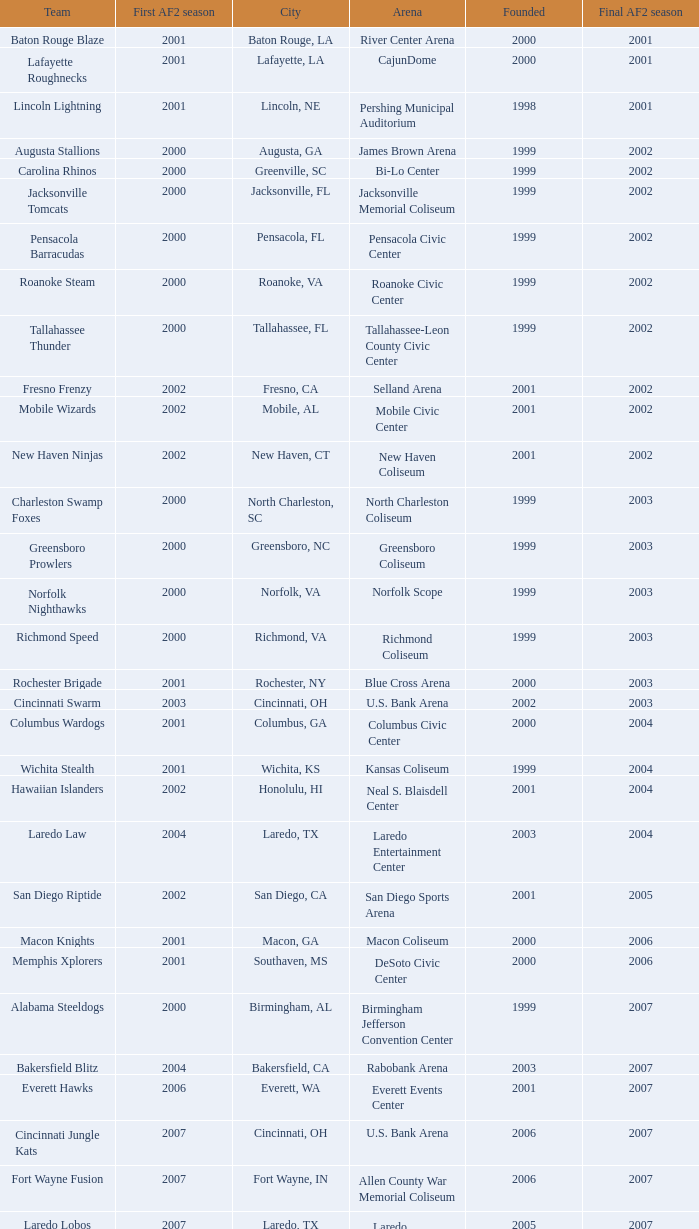How many founded years had a final af2 season prior to 2009 where the arena was the bi-lo center and the first af2 season was prior to 2000? 0.0. 